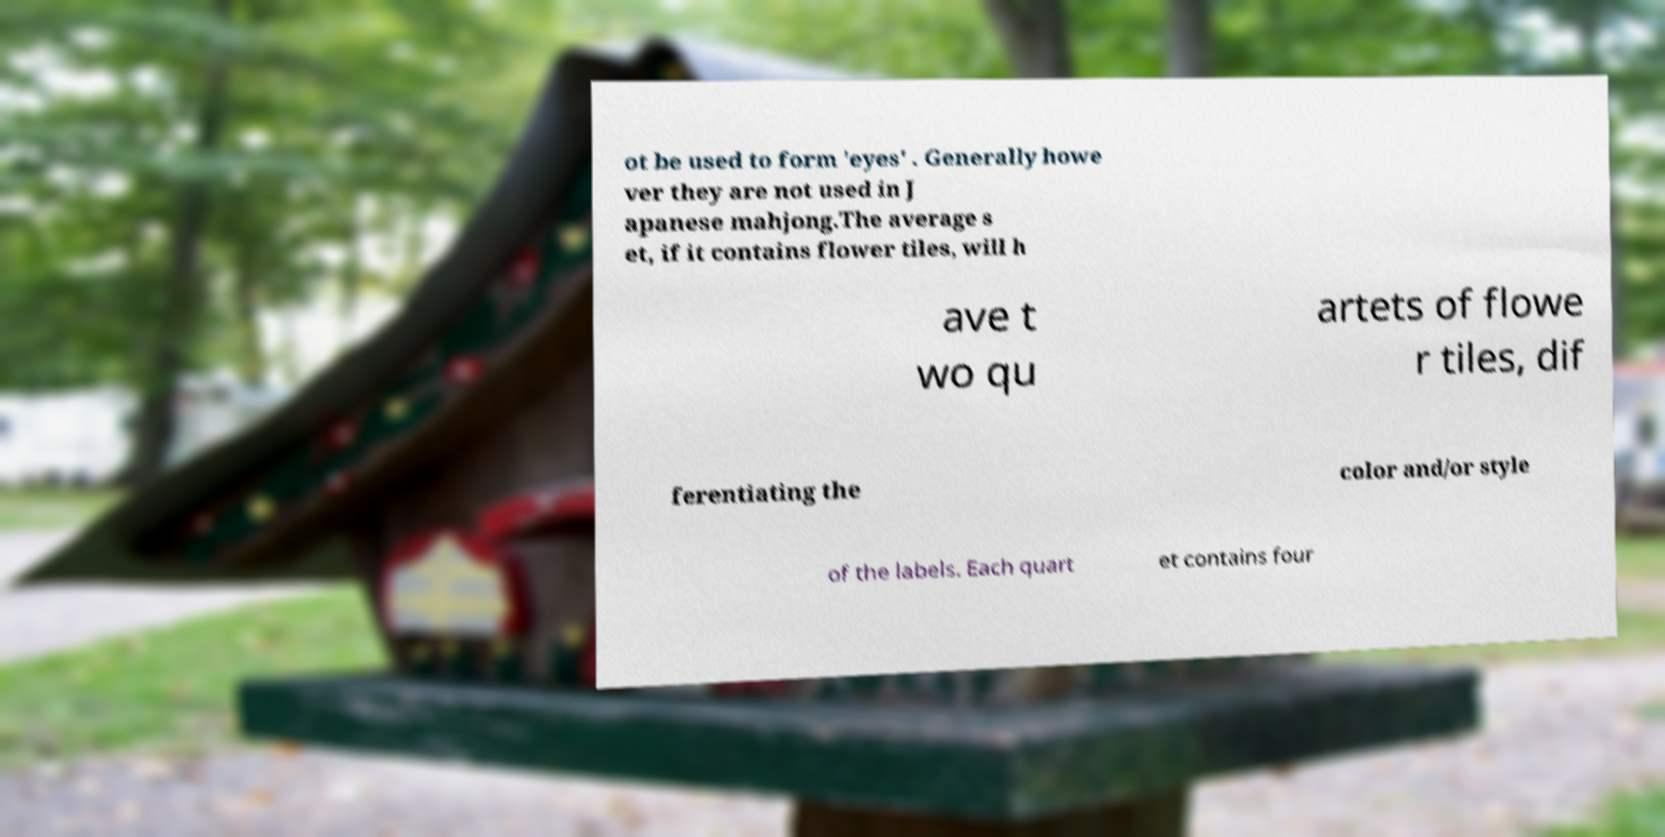Could you extract and type out the text from this image? ot be used to form 'eyes' . Generally howe ver they are not used in J apanese mahjong.The average s et, if it contains flower tiles, will h ave t wo qu artets of flowe r tiles, dif ferentiating the color and/or style of the labels. Each quart et contains four 